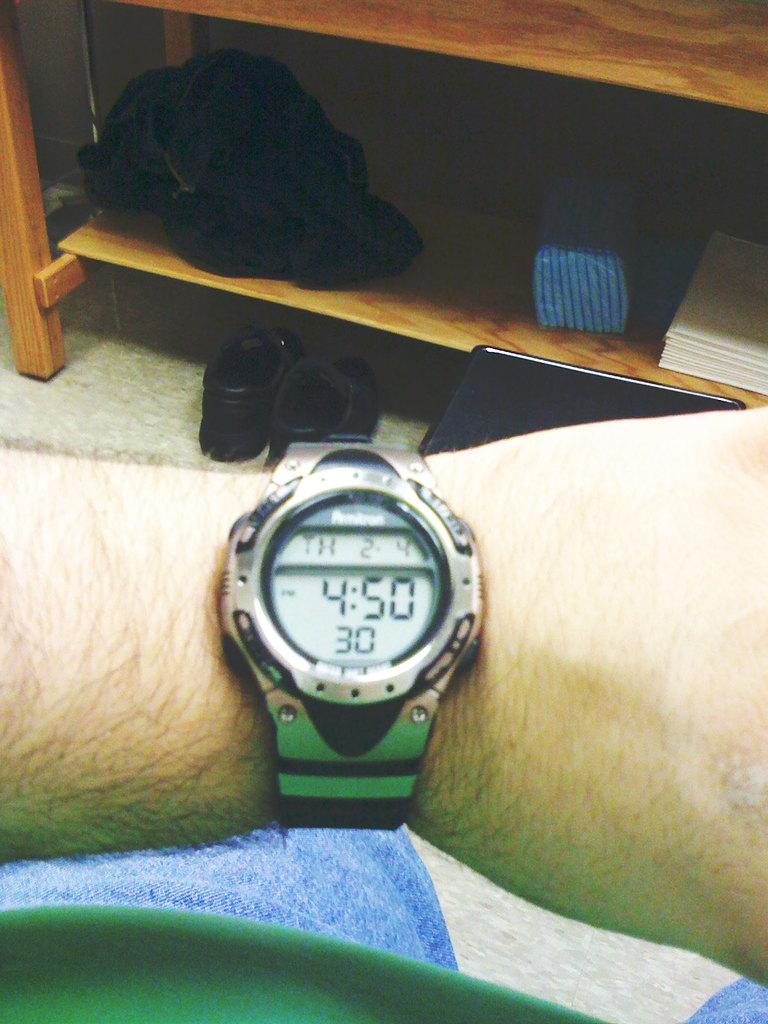<image>
Present a compact description of the photo's key features. A men's watch that shows 4:50 as the time. 